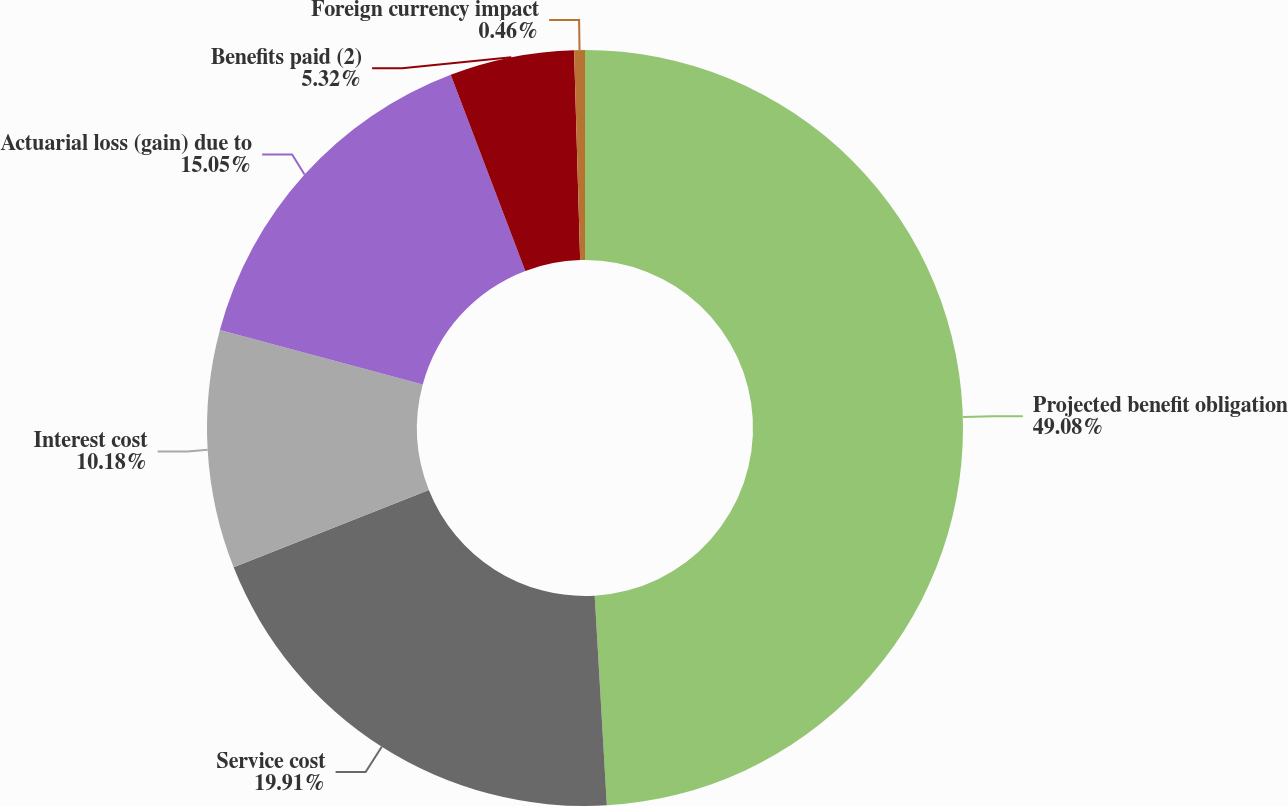Convert chart to OTSL. <chart><loc_0><loc_0><loc_500><loc_500><pie_chart><fcel>Projected benefit obligation<fcel>Service cost<fcel>Interest cost<fcel>Actuarial loss (gain) due to<fcel>Benefits paid (2)<fcel>Foreign currency impact<nl><fcel>49.08%<fcel>19.91%<fcel>10.18%<fcel>15.05%<fcel>5.32%<fcel>0.46%<nl></chart> 